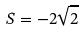Convert formula to latex. <formula><loc_0><loc_0><loc_500><loc_500>S = - 2 \sqrt { 2 }</formula> 